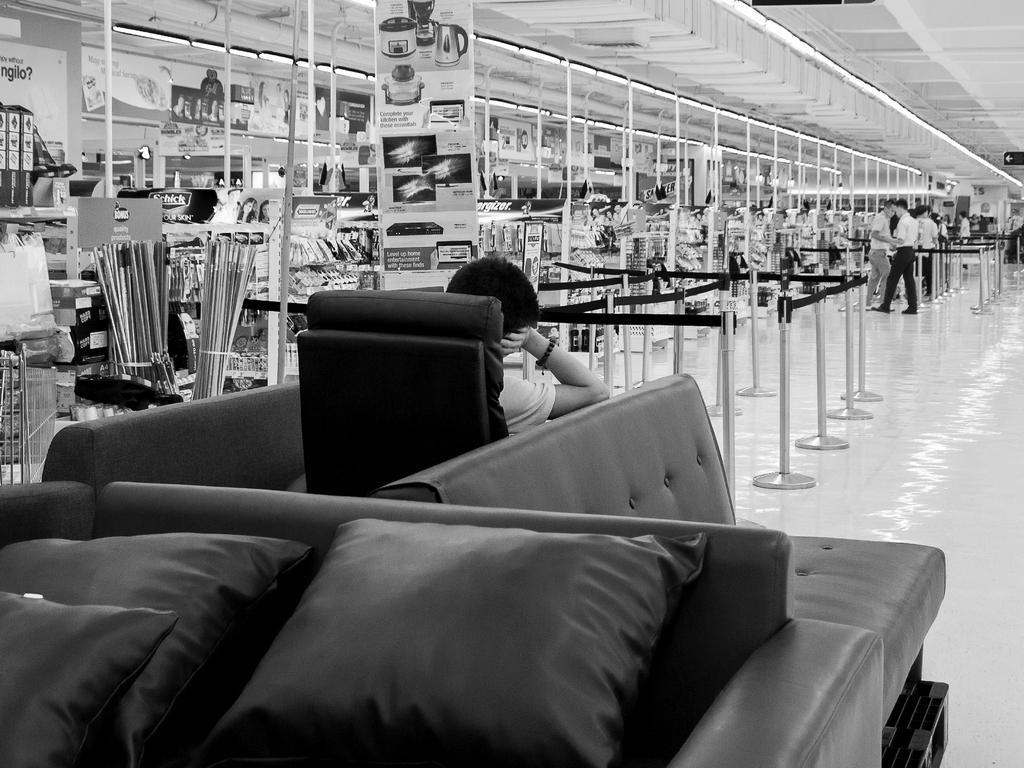How would you summarize this image in a sentence or two? It looks like a black and white picture. We can see there are cushions on the couch and a person is sitting on a chair. In front of the person there are retractable belt stanchions. There are some people are standing on the floor. On the left side of the people there are some objects and a board. At the top there are ceiling lights. 